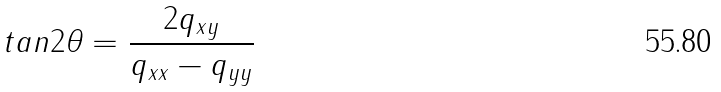Convert formula to latex. <formula><loc_0><loc_0><loc_500><loc_500>t a n 2 \theta = \frac { 2 q _ { x y } } { q _ { x x } - q _ { y y } }</formula> 